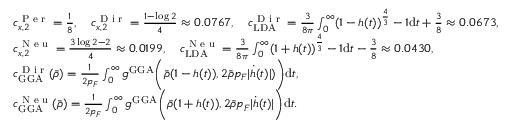<formula> <loc_0><loc_0><loc_500><loc_500>\begin{array} { r l } & { c _ { x , 2 } ^ { P e r } = \frac { 1 } { 8 } , \quad c _ { x , 2 } ^ { D i r } = \frac { 1 - \log 2 } { 4 } \approx 0 . 0 7 6 7 , \quad c _ { L D A } ^ { D i r } = \frac { 3 } { 8 \pi } \int _ { 0 } ^ { \infty } ( 1 - h ( t ) ) ^ { \frac { 4 } { 3 } } - 1 d t + \frac { 3 } { 8 } \approx 0 . 0 6 7 3 , } \\ & { c _ { x , 2 } ^ { N e u } = \frac { 3 \log 2 - 2 } { 4 } \approx 0 . 0 1 9 9 , \quad c _ { L D A } ^ { N e u } = \frac { 3 } { 8 \pi } \int _ { 0 } ^ { \infty } ( 1 + h ( t ) ) ^ { \frac { 4 } { 3 } } - 1 d t - \frac { 3 } { 8 } \approx 0 . 0 4 3 0 , } \\ & { c _ { G G A } ^ { D i r } ( \bar { \rho } ) = \frac { 1 } { 2 p _ { F } } \int _ { 0 } ^ { \infty } g ^ { G G A } \left ( \bar { \rho } ( 1 - h ( t ) ) , 2 \bar { \rho } p _ { F } | \dot { h } ( t ) | ) \right ) d t , } \\ & { c _ { G G A } ^ { N e u } ( \bar { \rho } ) = \frac { 1 } { 2 p _ { F } } \int _ { 0 } ^ { \infty } g ^ { G G A } \left ( \bar { \rho } ( 1 + h ( t ) ) , 2 \bar { \rho } p _ { F } | \dot { h } ( t ) | \right ) d t . } \end{array}</formula> 